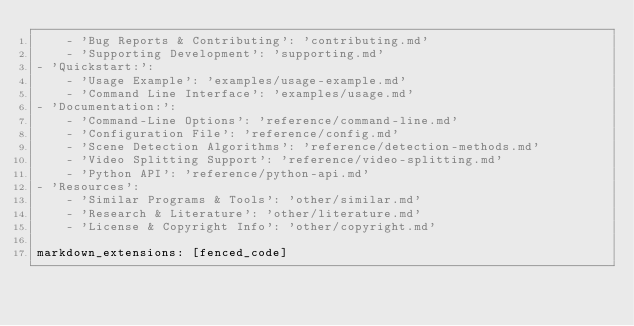<code> <loc_0><loc_0><loc_500><loc_500><_YAML_>    - 'Bug Reports & Contributing': 'contributing.md'
    - 'Supporting Development': 'supporting.md'
- 'Quickstart:':
    - 'Usage Example': 'examples/usage-example.md'
    - 'Command Line Interface': 'examples/usage.md'
- 'Documentation:':
    - 'Command-Line Options': 'reference/command-line.md'
    - 'Configuration File': 'reference/config.md'
    - 'Scene Detection Algorithms': 'reference/detection-methods.md'
    - 'Video Splitting Support': 'reference/video-splitting.md'
    - 'Python API': 'reference/python-api.md'
- 'Resources':
    - 'Similar Programs & Tools': 'other/similar.md'
    - 'Research & Literature': 'other/literature.md'
    - 'License & Copyright Info': 'other/copyright.md'

markdown_extensions: [fenced_code]
</code> 